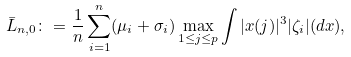Convert formula to latex. <formula><loc_0><loc_0><loc_500><loc_500>\bar { L } _ { n , 0 } \colon = \frac { 1 } { n } \sum _ { i = 1 } ^ { n } ( \mu _ { i } + \sigma _ { i } ) \max _ { 1 \leq j \leq p } \int | x ( j ) | ^ { 3 } | \zeta _ { i } | ( d x ) ,</formula> 